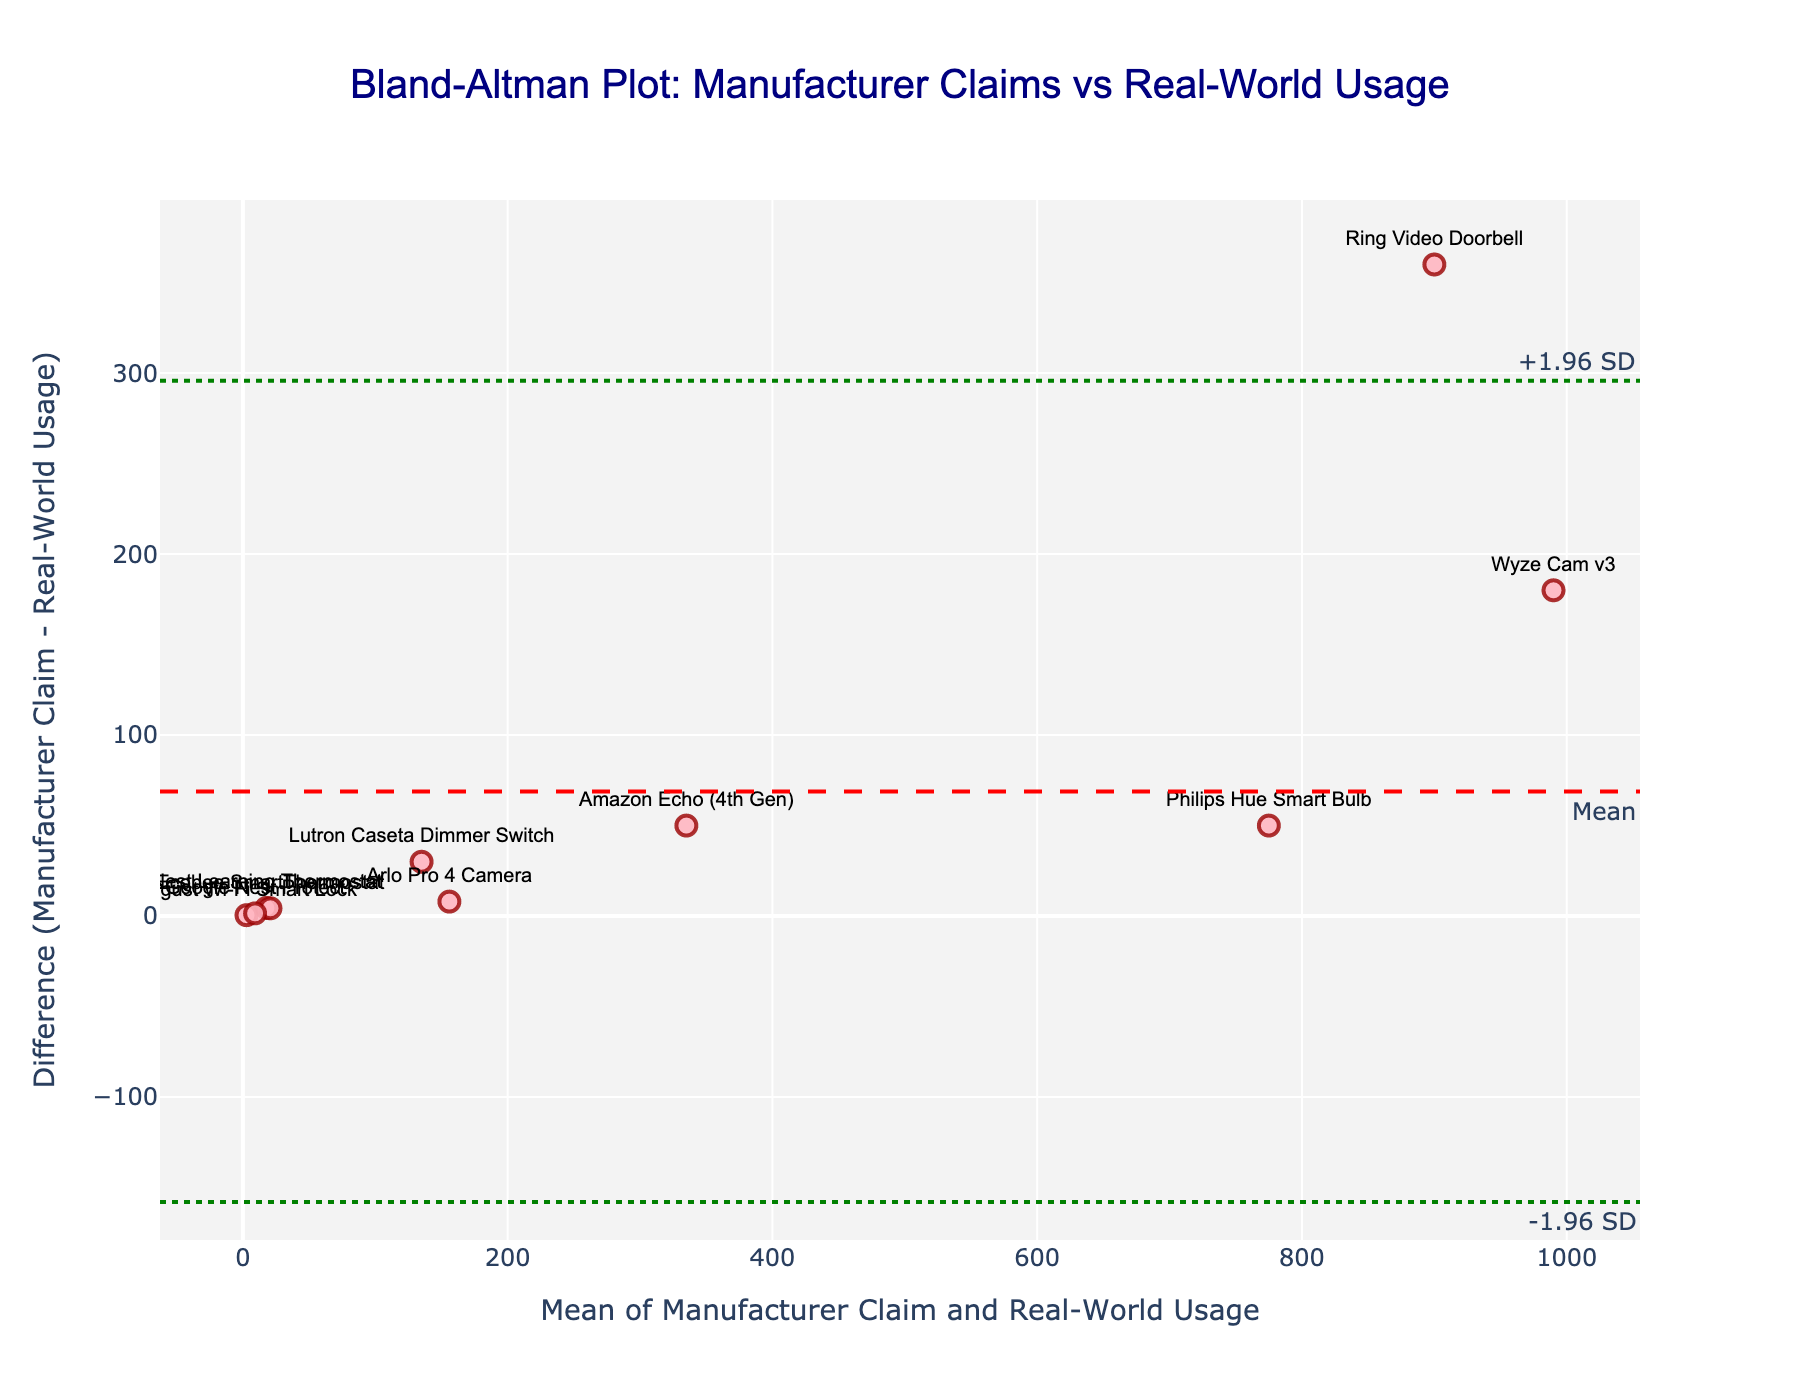What's the title of the plot? The title is displayed at the top center of the plot and often describes the main purpose of the figure. Here it is stated as "Bland-Altman Plot: Manufacturer Claims vs Real-World Usage".
Answer: Bland-Altman Plot: Manufacturer Claims vs Real-World Usage What are the x-axis and y-axis titles? The titles for the axes describe the type of data being represented on each axis. For this plot, the x-axis title is "Mean of Manufacturer Claim and Real-World Usage" and the y-axis title is "Difference (Manufacturer Claim - Real-World Usage)".
Answer: Mean of Manufacturer Claim and Real-World Usage, Difference (Manufacturer Claim - Real-World Usage) How many devices are represented in the plot? The number of devices corresponds to the number of data points on the scatter plot. Each device name is shown next to its corresponding marker. By counting these markers, we can see that there are 10 devices represented.
Answer: 10 What's the range of the x-axis? To determine the range of the x-axis, we can look at the minimum and maximum values marked on the x-axis. In the plot, the axis tick marks can help identify this range.
Answer: It varies depending on the data but needs to be inspected on the plot for exact min and max values Which device has the highest difference between Manufacturer Claim and Real-World Usage? To find this, we look at the y-axis values, which represent the difference. The device with the highest positive difference on the y-axis has the highest difference. Checking the plot, we notice that "Ring Video Doorbell" with a 360-degree sound difference occupies the highest point.
Answer: Ring Video Doorbell What is the mean difference (Manufacturer Claim - Real-World Usage)? The mean difference is indicated by the dashed red horizontal line. This value is annotated on the plot itself. The plot presents the mean difference visually.
Answer: Read value from the plot Which device shows the smallest deviation (absolute difference) from Manufacturer Claims? By comparing the markers closest to the y=0 line (where Manufacturer Claims equals Real-World Usage), we can identify the device with the smallest difference. Inspecting the plot, "Ecobee SmartThermostat" seems very close to this line.
Answer: Ecobee SmartThermostat How can we interpret the green dotted lines on the plot? The green dotted lines represent the limits of agreement, calculated as the mean difference plus or minus 1.96 times the standard deviation of the differences. They indicate the range within which most differences are expected to lie. These help assess the reliability of the differences.
Answer: Limits of agreement Is there any device with a negative difference? If so, which one has the most significant negative difference? Devices with a negative difference have usage values higher than claims. By looking at the markers below the y=0 line (negative y-values), we determine that "Google Nest Protect" has the most significant negative difference.
Answer: Google Nest Protect What insights can be derived by examining the spread of data points relative to the mean difference line? The distribution of data points around the mean difference line shows the consistency between manufacturer claims and real-world usage. A tight spread indicates high consistency, while a wide spread suggests variability. In this plot, some devices have small differences, indicating reliability, while others show significant deviations, hinting at less reliability.
Answer: It varies depending on the plot data 